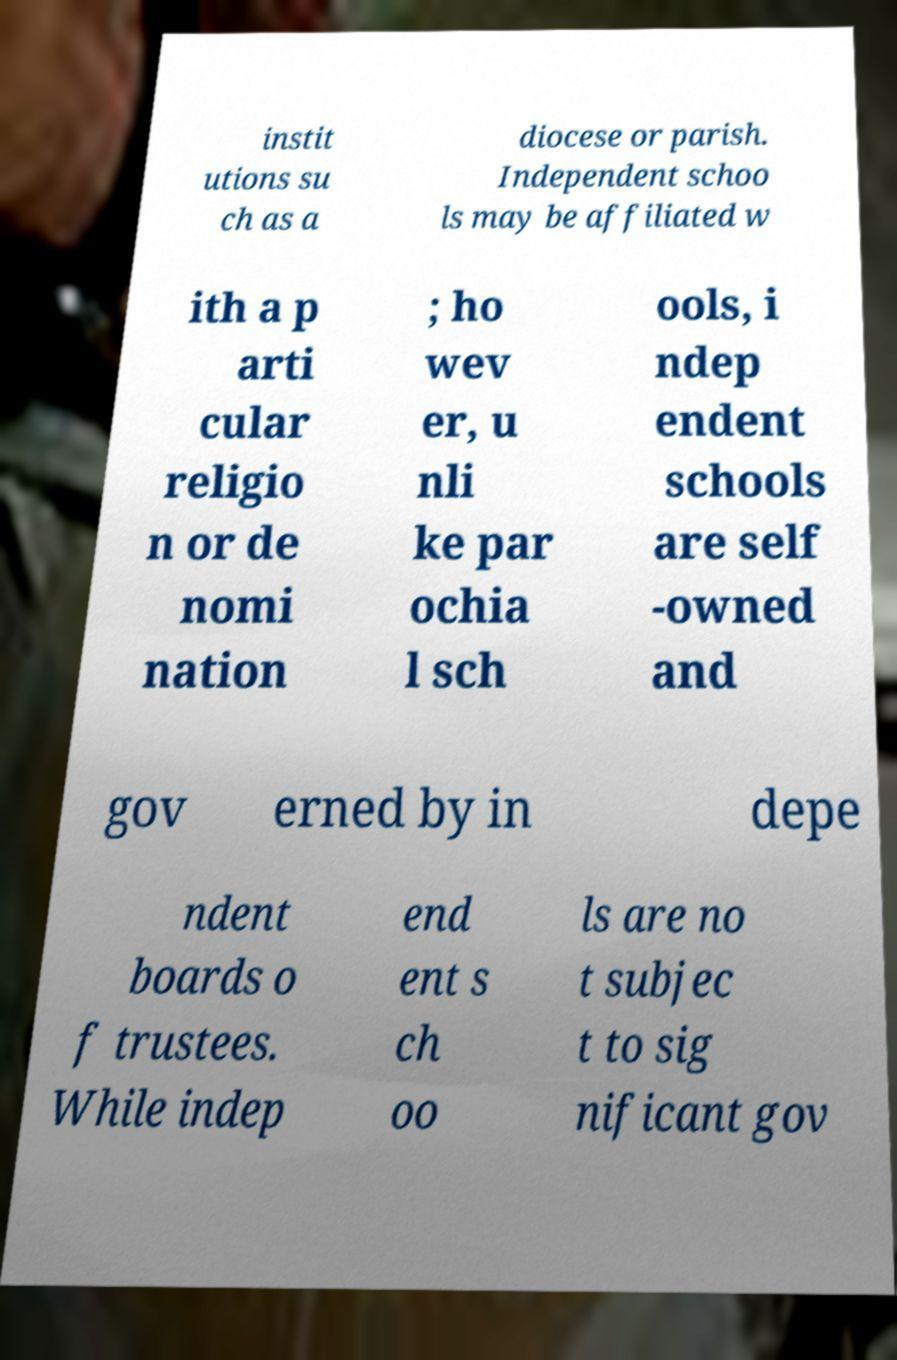What messages or text are displayed in this image? I need them in a readable, typed format. instit utions su ch as a diocese or parish. Independent schoo ls may be affiliated w ith a p arti cular religio n or de nomi nation ; ho wev er, u nli ke par ochia l sch ools, i ndep endent schools are self -owned and gov erned by in depe ndent boards o f trustees. While indep end ent s ch oo ls are no t subjec t to sig nificant gov 